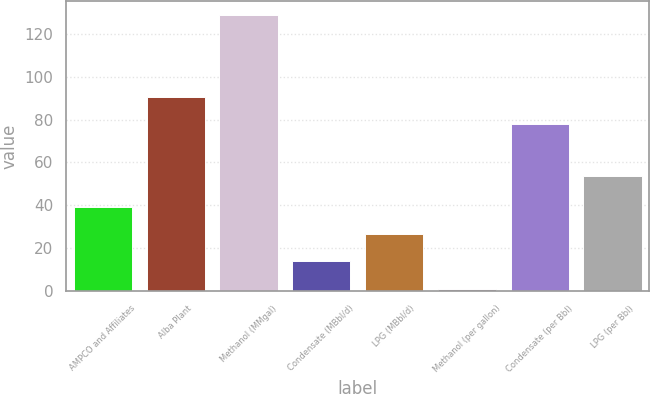Convert chart. <chart><loc_0><loc_0><loc_500><loc_500><bar_chart><fcel>AMPCO and Affiliates<fcel>Alba Plant<fcel>Methanol (MMgal)<fcel>Condensate (MBbl/d)<fcel>LPG (MBbl/d)<fcel>Methanol (per gallon)<fcel>Condensate (per Bbl)<fcel>LPG (per Bbl)<nl><fcel>39.3<fcel>90.8<fcel>129<fcel>13.66<fcel>26.48<fcel>0.84<fcel>77.98<fcel>53.68<nl></chart> 